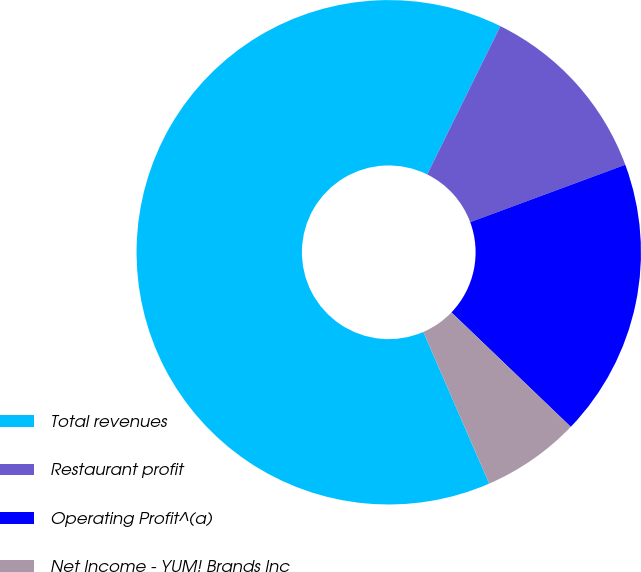Convert chart. <chart><loc_0><loc_0><loc_500><loc_500><pie_chart><fcel>Total revenues<fcel>Restaurant profit<fcel>Operating Profit^(a)<fcel>Net Income - YUM! Brands Inc<nl><fcel>63.82%<fcel>12.06%<fcel>17.81%<fcel>6.31%<nl></chart> 